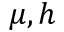Convert formula to latex. <formula><loc_0><loc_0><loc_500><loc_500>\mu , h</formula> 